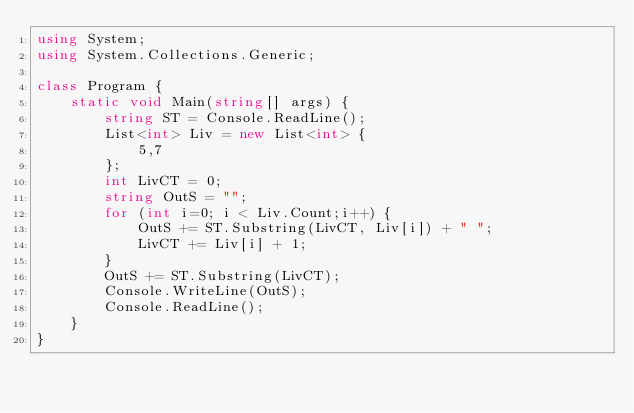<code> <loc_0><loc_0><loc_500><loc_500><_C#_>using System;
using System.Collections.Generic;

class Program {
    static void Main(string[] args) {
        string ST = Console.ReadLine();
        List<int> Liv = new List<int> {
            5,7
        };
        int LivCT = 0;
        string OutS = "";
        for (int i=0; i < Liv.Count;i++) {
            OutS += ST.Substring(LivCT, Liv[i]) + " ";
            LivCT += Liv[i] + 1;
        }
        OutS += ST.Substring(LivCT);
        Console.WriteLine(OutS);
        Console.ReadLine();
    }
}</code> 